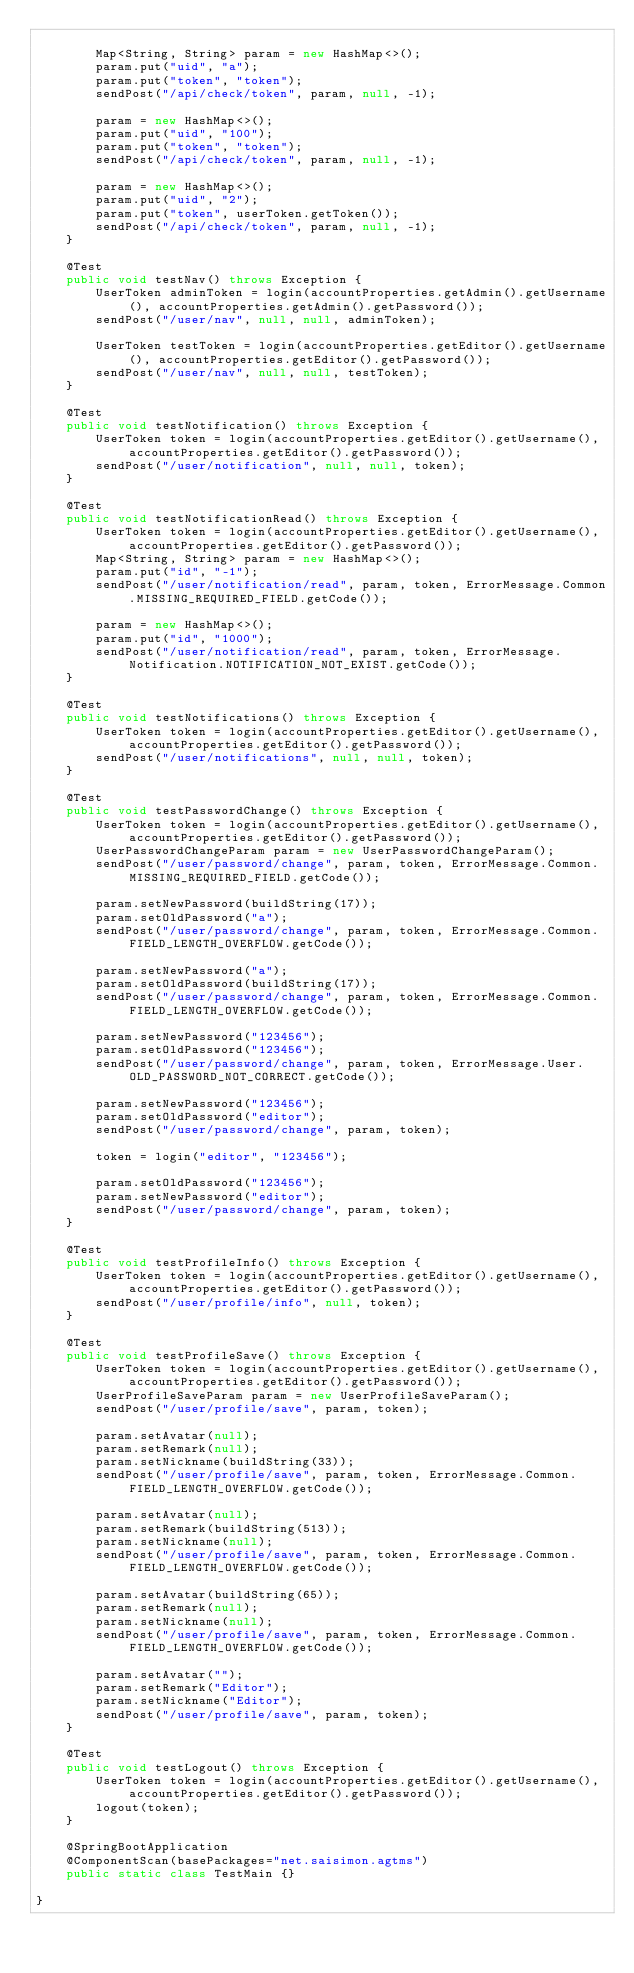Convert code to text. <code><loc_0><loc_0><loc_500><loc_500><_Java_>		
		Map<String, String> param = new HashMap<>();
		param.put("uid", "a");
		param.put("token", "token");
		sendPost("/api/check/token", param, null, -1);
		
		param = new HashMap<>();
		param.put("uid", "100");
		param.put("token", "token");
		sendPost("/api/check/token", param, null, -1);
		
		param = new HashMap<>();
		param.put("uid", "2");
		param.put("token", userToken.getToken());
		sendPost("/api/check/token", param, null, -1);
	}
	
	@Test
	public void testNav() throws Exception {
		UserToken adminToken = login(accountProperties.getAdmin().getUsername(), accountProperties.getAdmin().getPassword());
		sendPost("/user/nav", null, null, adminToken);
		
		UserToken testToken = login(accountProperties.getEditor().getUsername(), accountProperties.getEditor().getPassword());
		sendPost("/user/nav", null, null, testToken);
	}
	
	@Test
	public void testNotification() throws Exception {
		UserToken token = login(accountProperties.getEditor().getUsername(), accountProperties.getEditor().getPassword());
		sendPost("/user/notification", null, null, token);
	}
	
	@Test
	public void testNotificationRead() throws Exception {
		UserToken token = login(accountProperties.getEditor().getUsername(), accountProperties.getEditor().getPassword());
		Map<String, String> param = new HashMap<>();
		param.put("id", "-1");
		sendPost("/user/notification/read", param, token, ErrorMessage.Common.MISSING_REQUIRED_FIELD.getCode());
		
		param = new HashMap<>();
		param.put("id", "1000");
		sendPost("/user/notification/read", param, token, ErrorMessage.Notification.NOTIFICATION_NOT_EXIST.getCode());
	}
	
	@Test
	public void testNotifications() throws Exception {
		UserToken token = login(accountProperties.getEditor().getUsername(), accountProperties.getEditor().getPassword());
		sendPost("/user/notifications", null, null, token);
	}
	
	@Test
	public void testPasswordChange() throws Exception {
		UserToken token = login(accountProperties.getEditor().getUsername(), accountProperties.getEditor().getPassword());
		UserPasswordChangeParam param = new UserPasswordChangeParam();
		sendPost("/user/password/change", param, token, ErrorMessage.Common.MISSING_REQUIRED_FIELD.getCode());
		
		param.setNewPassword(buildString(17));
		param.setOldPassword("a");
		sendPost("/user/password/change", param, token, ErrorMessage.Common.FIELD_LENGTH_OVERFLOW.getCode());
		
		param.setNewPassword("a");
		param.setOldPassword(buildString(17));
		sendPost("/user/password/change", param, token, ErrorMessage.Common.FIELD_LENGTH_OVERFLOW.getCode());
		
		param.setNewPassword("123456");
		param.setOldPassword("123456");
		sendPost("/user/password/change", param, token, ErrorMessage.User.OLD_PASSWORD_NOT_CORRECT.getCode());
		
		param.setNewPassword("123456");
		param.setOldPassword("editor");
		sendPost("/user/password/change", param, token);
		
		token = login("editor", "123456");
		
		param.setOldPassword("123456");
		param.setNewPassword("editor");
		sendPost("/user/password/change", param, token);
	}
	
	@Test
	public void testProfileInfo() throws Exception {
		UserToken token = login(accountProperties.getEditor().getUsername(), accountProperties.getEditor().getPassword());
		sendPost("/user/profile/info", null, token);
	}
	
	@Test
	public void testProfileSave() throws Exception {
		UserToken token = login(accountProperties.getEditor().getUsername(), accountProperties.getEditor().getPassword());
		UserProfileSaveParam param = new UserProfileSaveParam();
		sendPost("/user/profile/save", param, token);
		
		param.setAvatar(null);
		param.setRemark(null);
		param.setNickname(buildString(33));
		sendPost("/user/profile/save", param, token, ErrorMessage.Common.FIELD_LENGTH_OVERFLOW.getCode());
		
		param.setAvatar(null);
		param.setRemark(buildString(513));
		param.setNickname(null);
		sendPost("/user/profile/save", param, token, ErrorMessage.Common.FIELD_LENGTH_OVERFLOW.getCode());
		
		param.setAvatar(buildString(65));
		param.setRemark(null);
		param.setNickname(null);
		sendPost("/user/profile/save", param, token, ErrorMessage.Common.FIELD_LENGTH_OVERFLOW.getCode());
		
		param.setAvatar("");
		param.setRemark("Editor");
		param.setNickname("Editor");
		sendPost("/user/profile/save", param, token);
	}
	
	@Test
	public void testLogout() throws Exception {
		UserToken token = login(accountProperties.getEditor().getUsername(), accountProperties.getEditor().getPassword());
		logout(token);
	}
	
	@SpringBootApplication
	@ComponentScan(basePackages="net.saisimon.agtms")
	public static class TestMain {}
	
}
</code> 